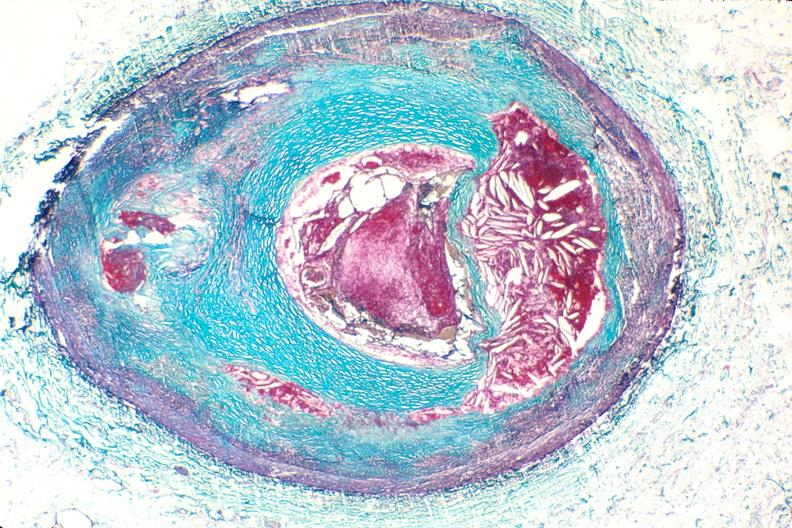what is present?
Answer the question using a single word or phrase. Vasculature 